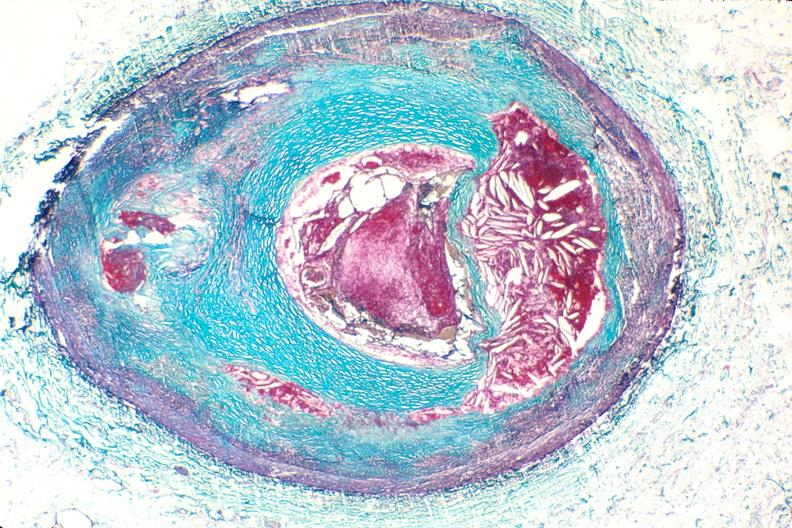what is present?
Answer the question using a single word or phrase. Vasculature 